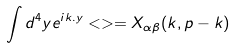<formula> <loc_0><loc_0><loc_500><loc_500>\int d ^ { 4 } y e ^ { i k . y } < > = X _ { \alpha \beta } ( k , p - k )</formula> 